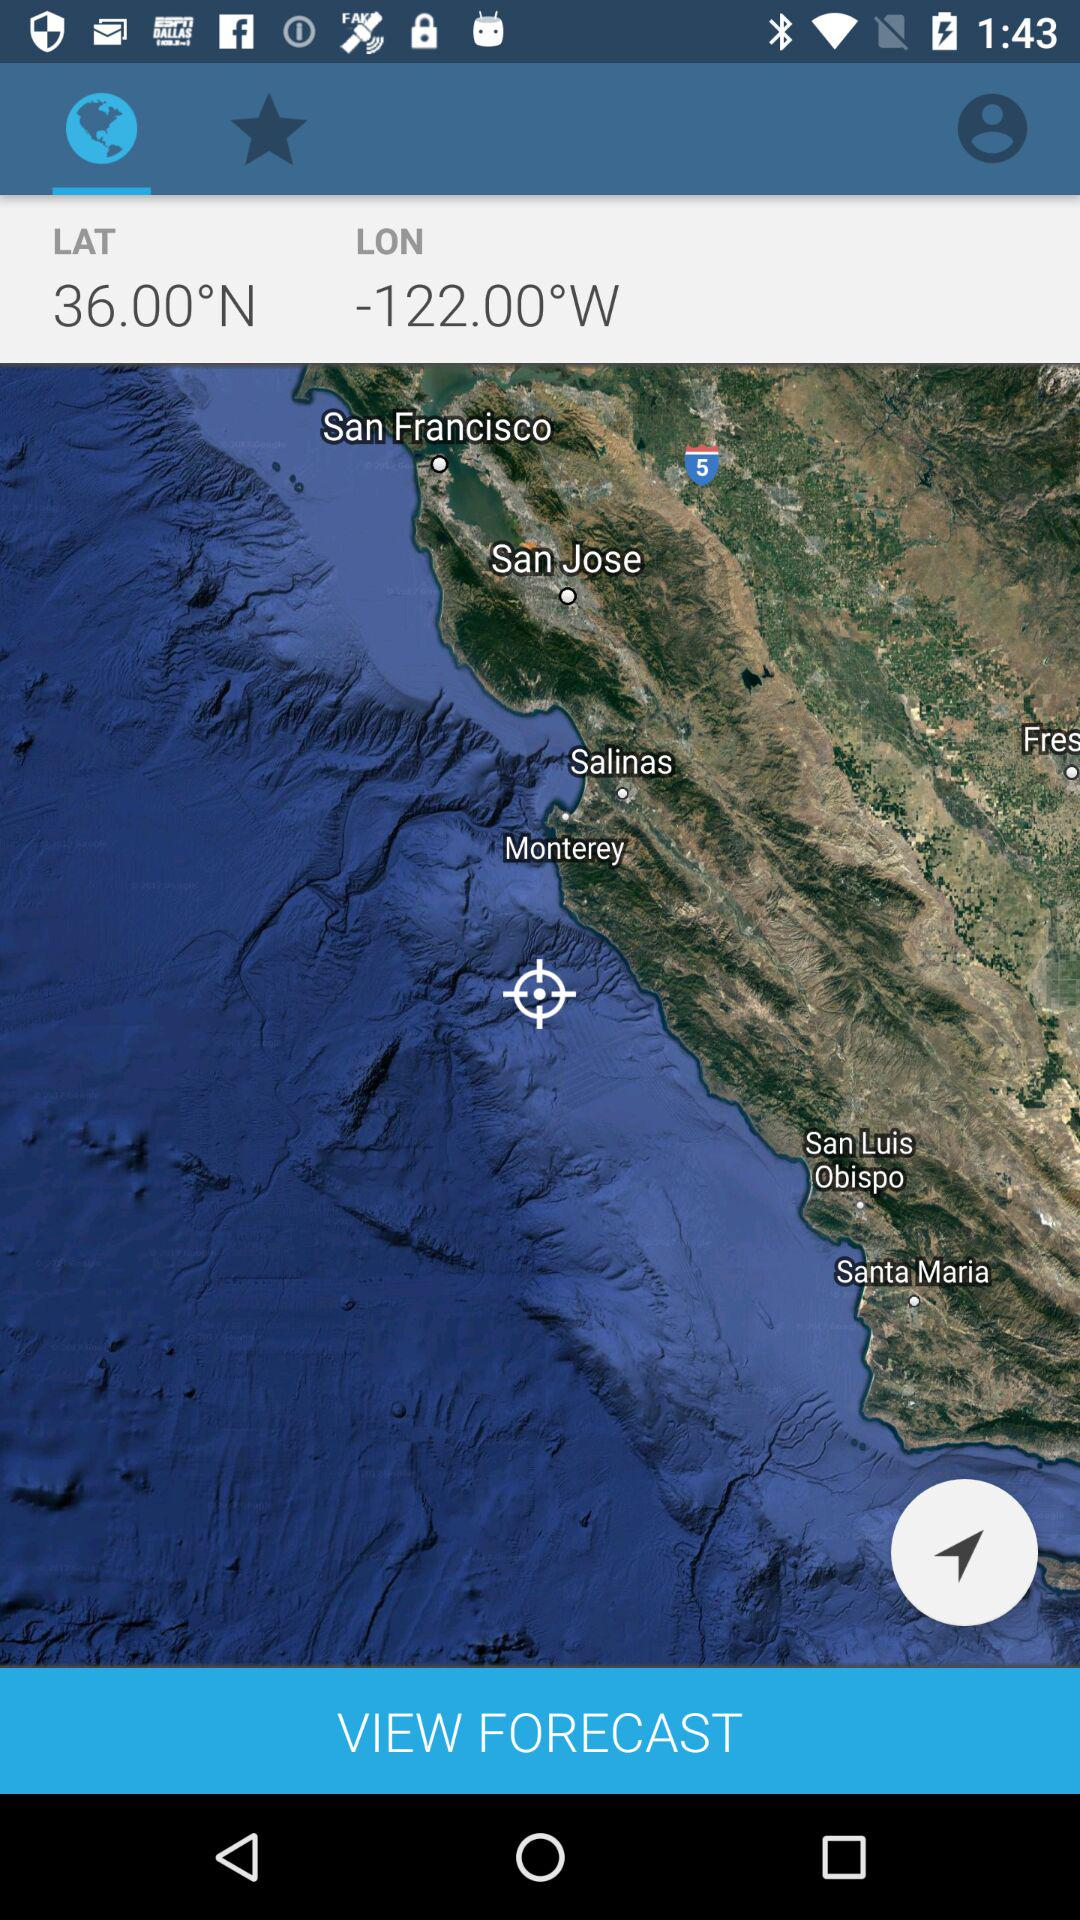What's the longitude? The longitude is -122.00° W. 